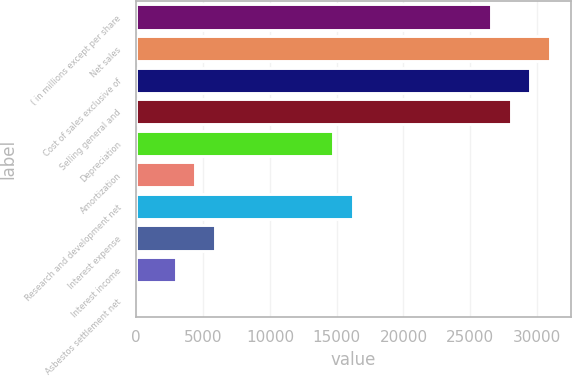<chart> <loc_0><loc_0><loc_500><loc_500><bar_chart><fcel>( in millions except per share<fcel>Net sales<fcel>Cost of sales exclusive of<fcel>Selling general and<fcel>Depreciation<fcel>Amortization<fcel>Research and development net<fcel>Interest expense<fcel>Interest income<fcel>Asbestos settlement net<nl><fcel>26547.8<fcel>30971.6<fcel>29497<fcel>28022.4<fcel>14751<fcel>4428.8<fcel>16225.6<fcel>5903.4<fcel>2954.2<fcel>5<nl></chart> 